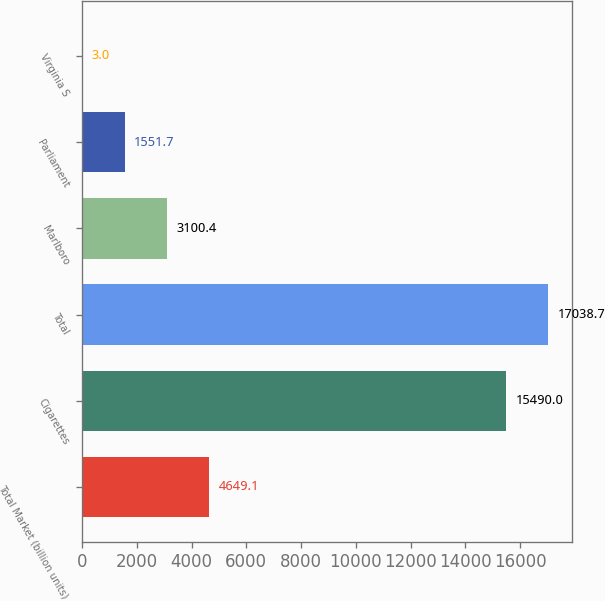Convert chart to OTSL. <chart><loc_0><loc_0><loc_500><loc_500><bar_chart><fcel>Total Market (billion units)<fcel>Cigarettes<fcel>Total<fcel>Marlboro<fcel>Parliament<fcel>Virginia S<nl><fcel>4649.1<fcel>15490<fcel>17038.7<fcel>3100.4<fcel>1551.7<fcel>3<nl></chart> 